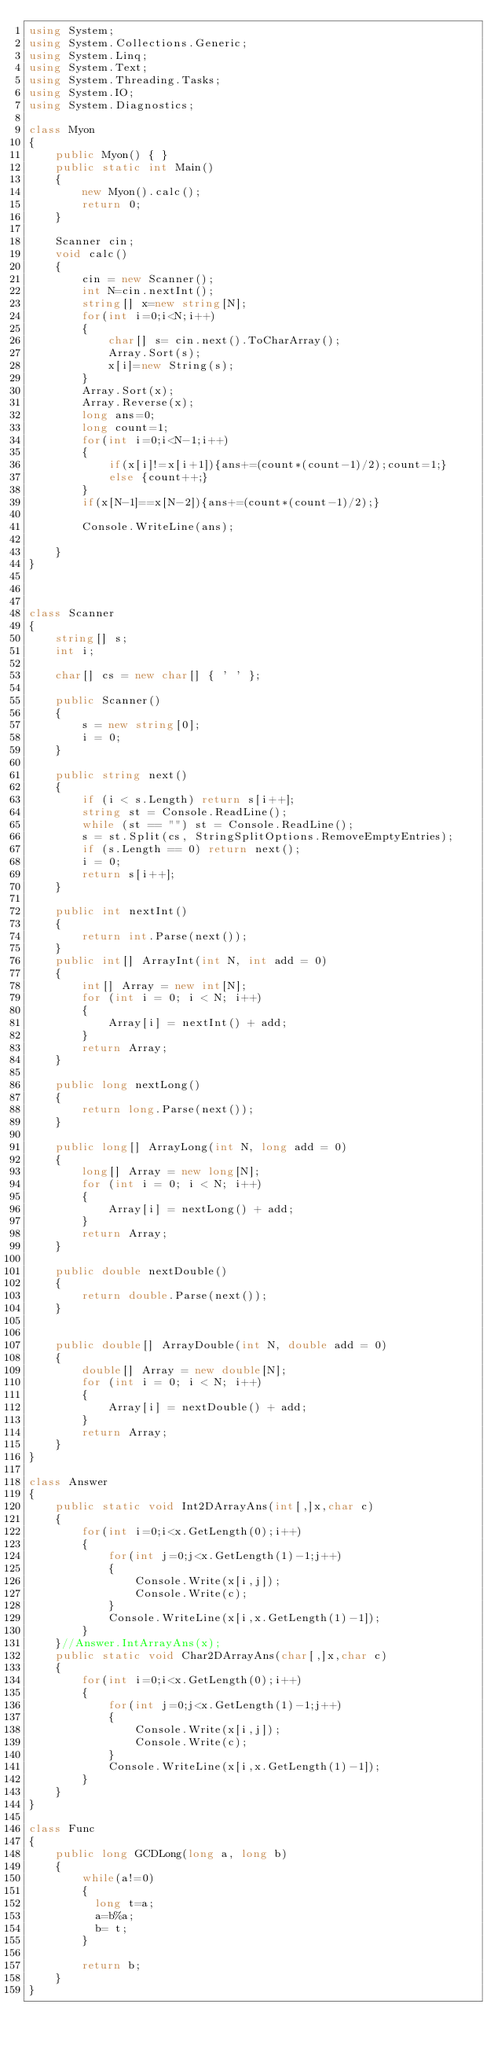<code> <loc_0><loc_0><loc_500><loc_500><_C#_>using System;
using System.Collections.Generic;
using System.Linq;
using System.Text;
using System.Threading.Tasks;
using System.IO;
using System.Diagnostics;

class Myon
{
    public Myon() { }
    public static int Main()
    {
        new Myon().calc();
        return 0;
    }

    Scanner cin;
    void calc()
    {
        cin = new Scanner();
        int N=cin.nextInt();
        string[] x=new string[N];
        for(int i=0;i<N;i++)
        {
            char[] s= cin.next().ToCharArray();
            Array.Sort(s);
            x[i]=new String(s);
        }
        Array.Sort(x);
        Array.Reverse(x);
        long ans=0;
        long count=1;
        for(int i=0;i<N-1;i++)
        {
            if(x[i]!=x[i+1]){ans+=(count*(count-1)/2);count=1;}
            else {count++;}
        }
        if(x[N-1]==x[N-2]){ans+=(count*(count-1)/2);}
        
        Console.WriteLine(ans);
        
    }
}



class Scanner
{
    string[] s;
    int i;

    char[] cs = new char[] { ' ' };

    public Scanner()
    {
        s = new string[0];
        i = 0;
    }

    public string next()
    {
        if (i < s.Length) return s[i++];
        string st = Console.ReadLine();
        while (st == "") st = Console.ReadLine();
        s = st.Split(cs, StringSplitOptions.RemoveEmptyEntries);
        if (s.Length == 0) return next();
        i = 0;
        return s[i++];
    }

    public int nextInt()
    {
        return int.Parse(next());
    }
    public int[] ArrayInt(int N, int add = 0)
    {
        int[] Array = new int[N];
        for (int i = 0; i < N; i++)
        {
            Array[i] = nextInt() + add;
        }
        return Array;
    }

    public long nextLong()
    {
        return long.Parse(next());
    }

    public long[] ArrayLong(int N, long add = 0)
    {
        long[] Array = new long[N];
        for (int i = 0; i < N; i++)
        {
            Array[i] = nextLong() + add;
        }
        return Array;
    }

    public double nextDouble()
    {
        return double.Parse(next());
    }


    public double[] ArrayDouble(int N, double add = 0)
    {
        double[] Array = new double[N];
        for (int i = 0; i < N; i++)
        {
            Array[i] = nextDouble() + add;
        }
        return Array;
    }
}

class Answer
{
    public static void Int2DArrayAns(int[,]x,char c)
    {
        for(int i=0;i<x.GetLength(0);i++)
        {
            for(int j=0;j<x.GetLength(1)-1;j++)
            {
                Console.Write(x[i,j]);
                Console.Write(c);
            }
            Console.WriteLine(x[i,x.GetLength(1)-1]);
        }
    }//Answer.IntArrayAns(x);
    public static void Char2DArrayAns(char[,]x,char c)
    {
        for(int i=0;i<x.GetLength(0);i++)
        {
            for(int j=0;j<x.GetLength(1)-1;j++)
            {
                Console.Write(x[i,j]);
                Console.Write(c);
            }
            Console.WriteLine(x[i,x.GetLength(1)-1]);
        }
    }
}

class Func
{
    public long GCDLong(long a, long b)
    {
        while(a!=0)
        {
          long t=a;
          a=b%a;
          b= t;
        }
      
        return b;        
    }
}
</code> 